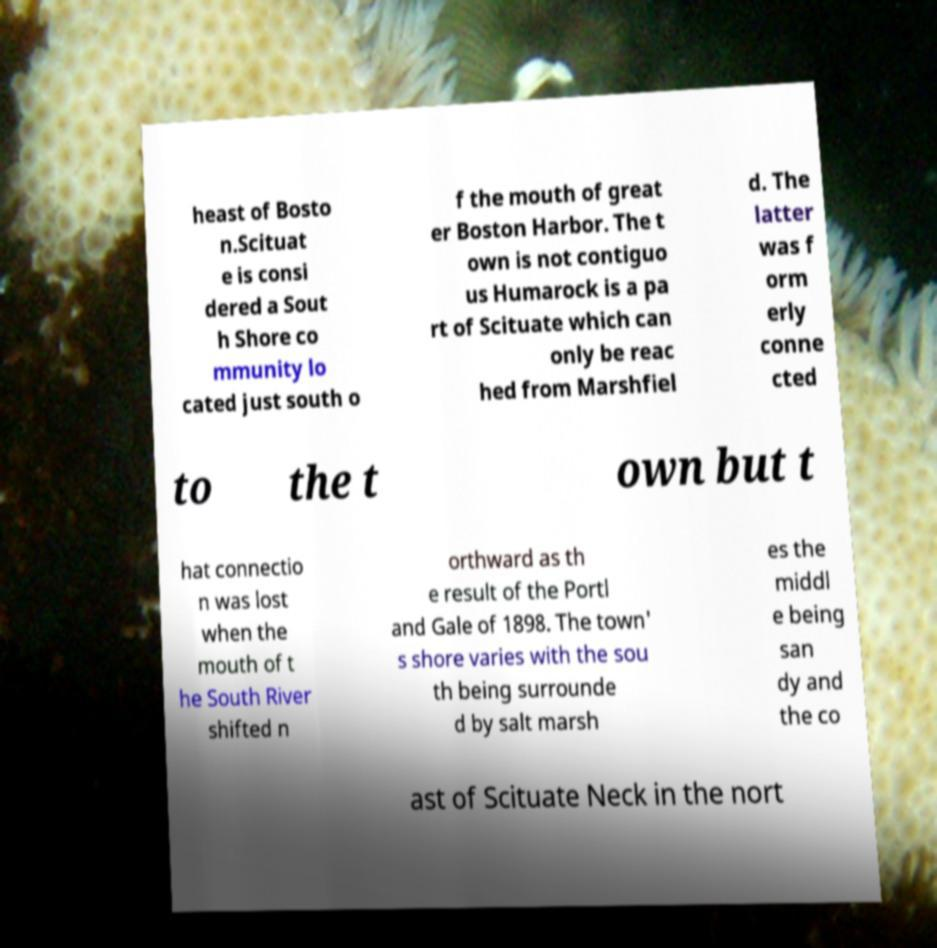Please identify and transcribe the text found in this image. heast of Bosto n.Scituat e is consi dered a Sout h Shore co mmunity lo cated just south o f the mouth of great er Boston Harbor. The t own is not contiguo us Humarock is a pa rt of Scituate which can only be reac hed from Marshfiel d. The latter was f orm erly conne cted to the t own but t hat connectio n was lost when the mouth of t he South River shifted n orthward as th e result of the Portl and Gale of 1898. The town' s shore varies with the sou th being surrounde d by salt marsh es the middl e being san dy and the co ast of Scituate Neck in the nort 